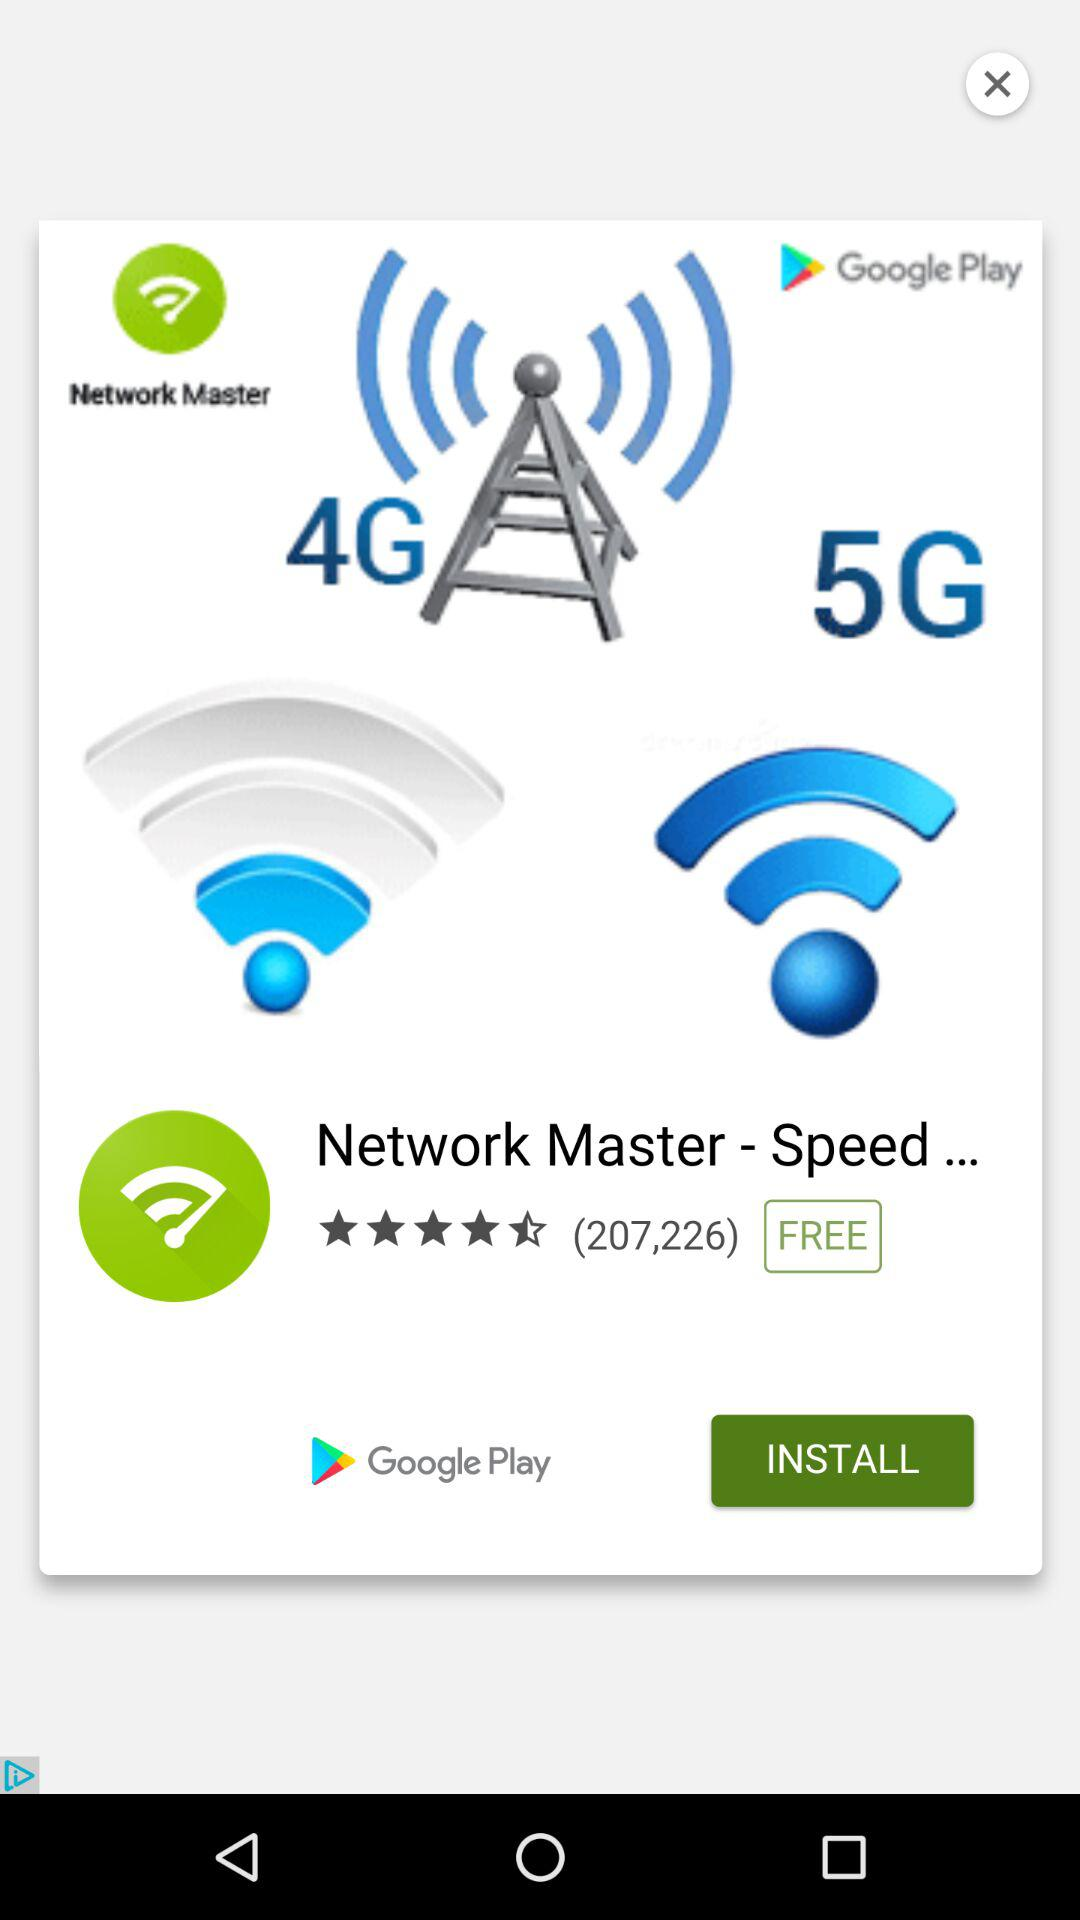What is the average rating of the app?
Answer the question using a single word or phrase. 4.5 